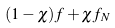<formula> <loc_0><loc_0><loc_500><loc_500>( 1 - \chi ) f + \chi f _ { N }</formula> 